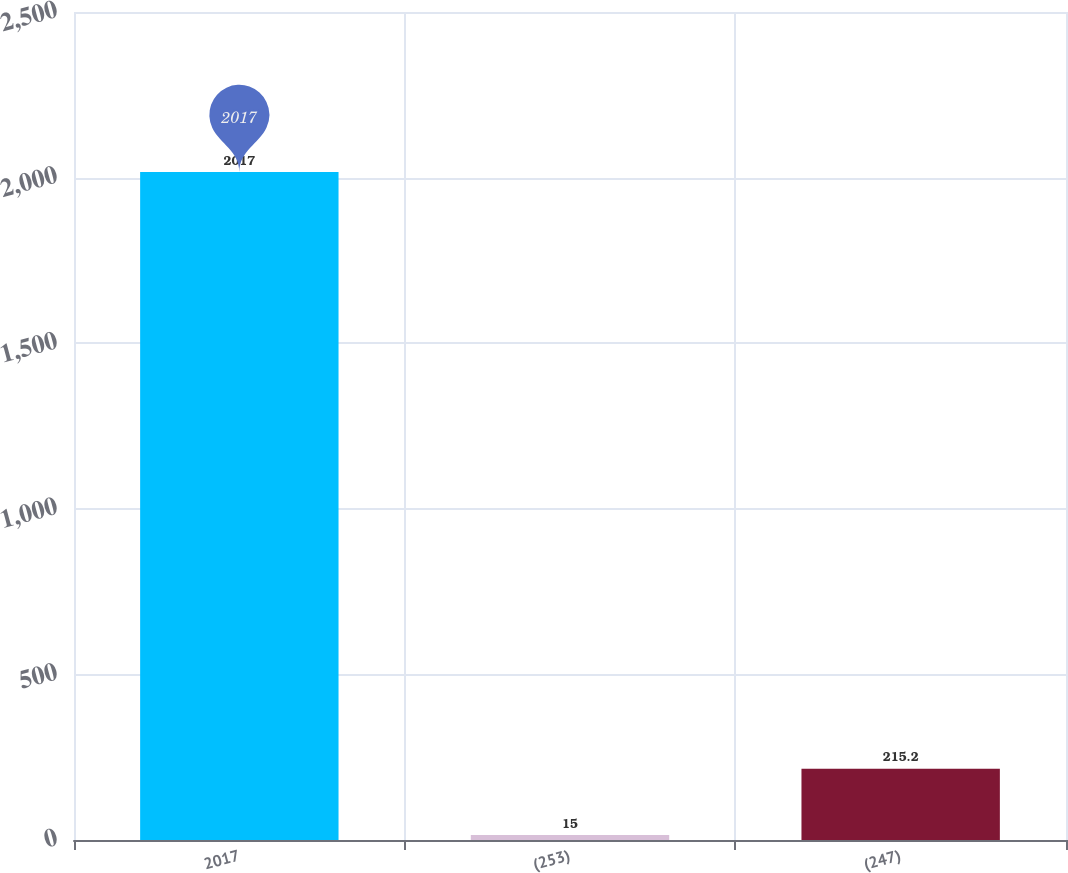<chart> <loc_0><loc_0><loc_500><loc_500><bar_chart><fcel>2017<fcel>(253)<fcel>(247)<nl><fcel>2017<fcel>15<fcel>215.2<nl></chart> 